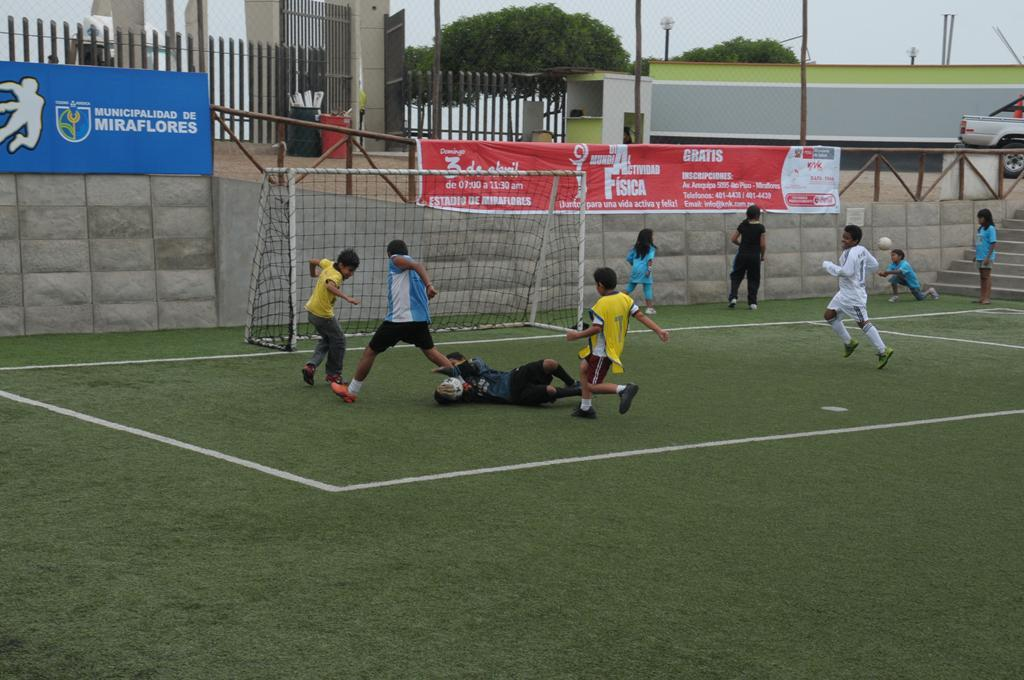What can be seen in the image? There are kids in the image. Where are the kids playing? The kids are playing in a playground. What sport are the kids playing? The kids are playing football. What equipment is used for playing football in the image? There is a goal net in the image. What can be seen in the background of the image? There are many trees in the background of the image. What type of jeans are the kids wearing in the image? There is no information about the kids' clothing in the image, so it cannot be determined if they are wearing jeans or any other type of clothing. 